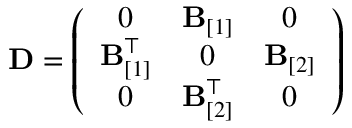Convert formula to latex. <formula><loc_0><loc_0><loc_500><loc_500>{ D } = \left ( \begin{array} { c c c } { 0 } & { { B } _ { [ 1 ] } } & { 0 } \\ { { B } _ { [ 1 ] } ^ { \top } } & { 0 } & { { B } _ { [ 2 ] } } \\ { 0 } & { { B } _ { [ 2 ] } ^ { \top } } & { 0 } \end{array} \right )</formula> 